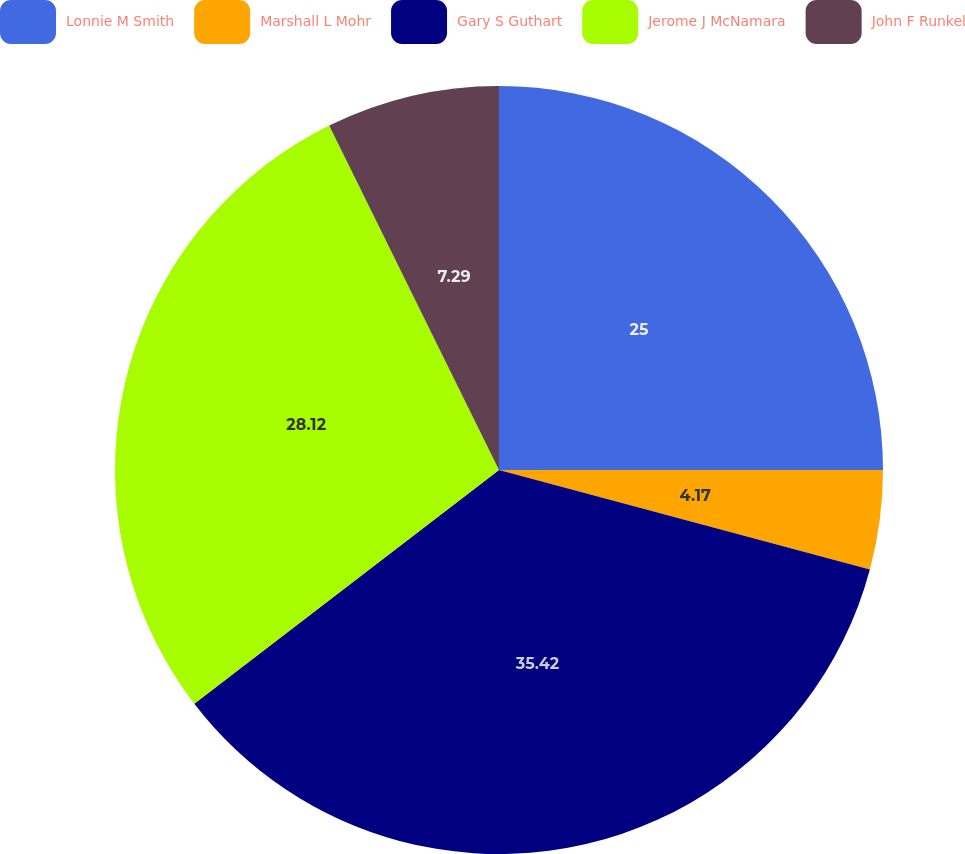Convert chart to OTSL. <chart><loc_0><loc_0><loc_500><loc_500><pie_chart><fcel>Lonnie M Smith<fcel>Marshall L Mohr<fcel>Gary S Guthart<fcel>Jerome J McNamara<fcel>John F Runkel<nl><fcel>25.0%<fcel>4.17%<fcel>35.41%<fcel>28.12%<fcel>7.29%<nl></chart> 